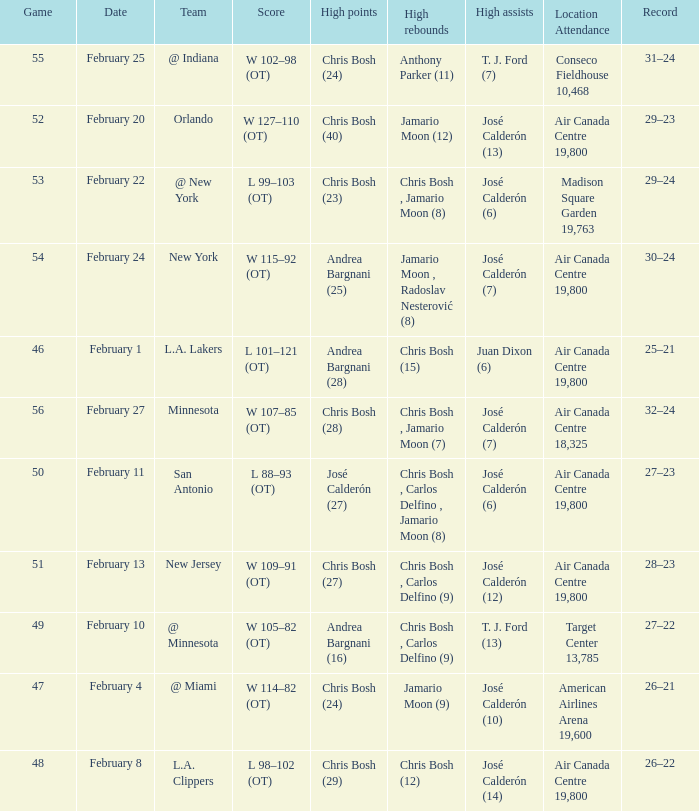Who scored the most points in Game 49? Andrea Bargnani (16). 